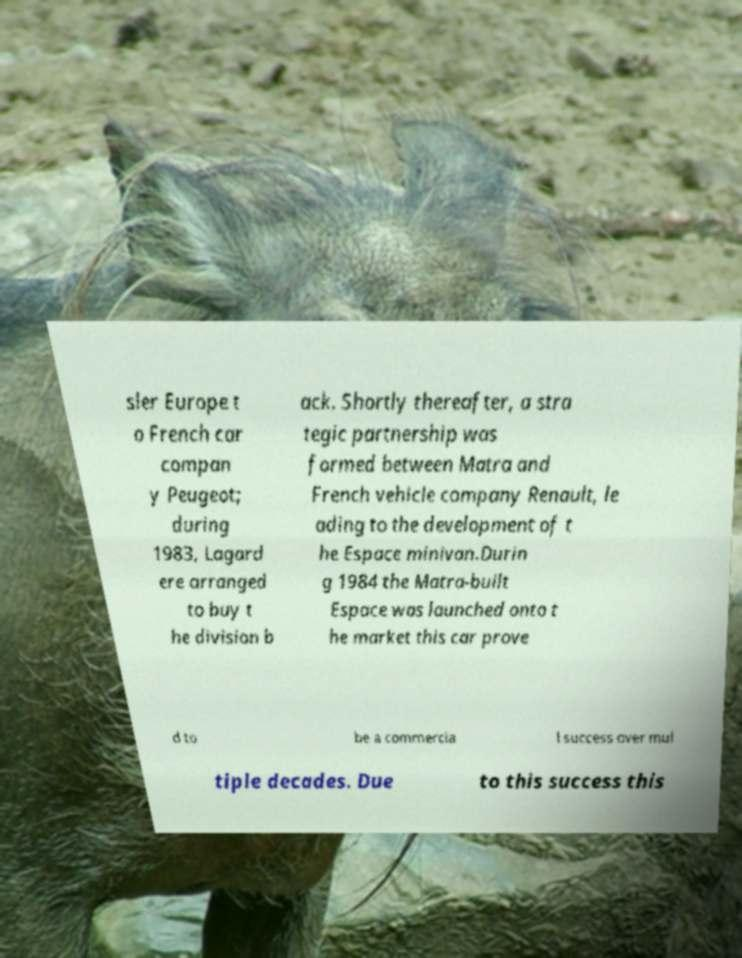For documentation purposes, I need the text within this image transcribed. Could you provide that? sler Europe t o French car compan y Peugeot; during 1983, Lagard ere arranged to buy t he division b ack. Shortly thereafter, a stra tegic partnership was formed between Matra and French vehicle company Renault, le ading to the development of t he Espace minivan.Durin g 1984 the Matra-built Espace was launched onto t he market this car prove d to be a commercia l success over mul tiple decades. Due to this success this 